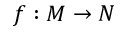Convert formula to latex. <formula><loc_0><loc_0><loc_500><loc_500>f \colon M \rightarrow N</formula> 